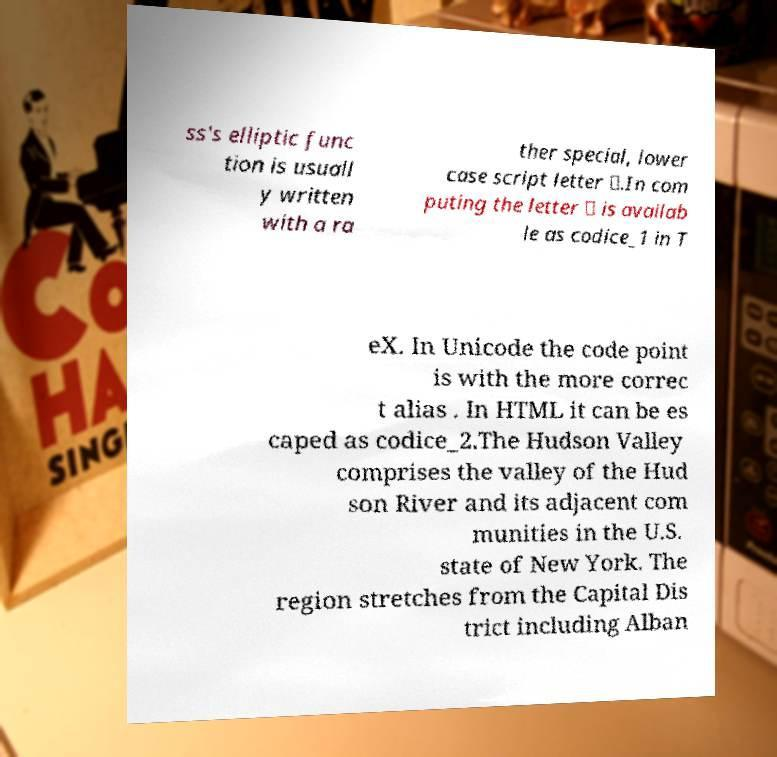Could you extract and type out the text from this image? ss's elliptic func tion is usuall y written with a ra ther special, lower case script letter ℘.In com puting the letter ℘ is availab le as codice_1 in T eX. In Unicode the code point is with the more correc t alias . In HTML it can be es caped as codice_2.The Hudson Valley comprises the valley of the Hud son River and its adjacent com munities in the U.S. state of New York. The region stretches from the Capital Dis trict including Alban 